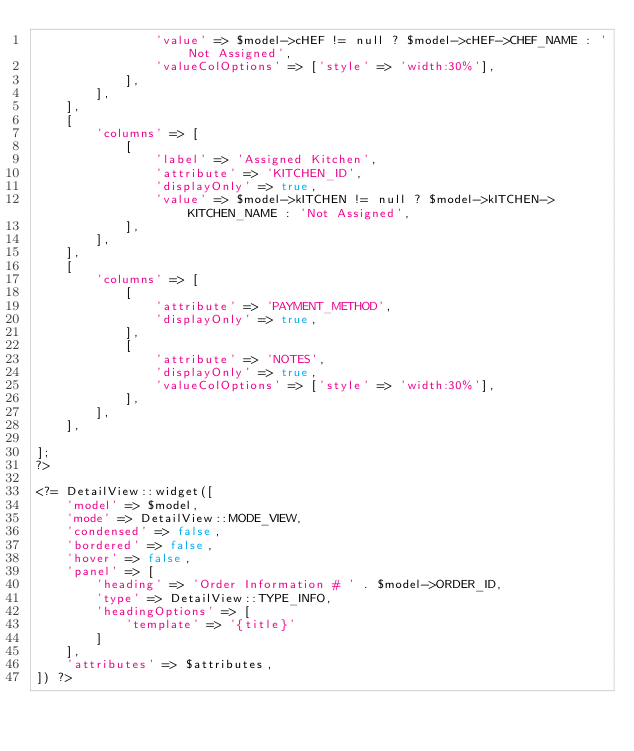Convert code to text. <code><loc_0><loc_0><loc_500><loc_500><_PHP_>                'value' => $model->cHEF != null ? $model->cHEF->CHEF_NAME : 'Not Assigned',
                'valueColOptions' => ['style' => 'width:30%'],
            ],
        ],
    ],
    [
        'columns' => [
            [
                'label' => 'Assigned Kitchen',
                'attribute' => 'KITCHEN_ID',
                'displayOnly' => true,
                'value' => $model->kITCHEN != null ? $model->kITCHEN->KITCHEN_NAME : 'Not Assigned',
            ],
        ],
    ],
    [
        'columns' => [
            [
                'attribute' => 'PAYMENT_METHOD',
                'displayOnly' => true,
            ],
            [
                'attribute' => 'NOTES',
                'displayOnly' => true,
                'valueColOptions' => ['style' => 'width:30%'],
            ],
        ],
    ],

];
?>

<?= DetailView::widget([
    'model' => $model,
    'mode' => DetailView::MODE_VIEW,
    'condensed' => false,
    'bordered' => false,
    'hover' => false,
    'panel' => [
        'heading' => 'Order Information # ' . $model->ORDER_ID,
        'type' => DetailView::TYPE_INFO,
        'headingOptions' => [
            'template' => '{title}'
        ]
    ],
    'attributes' => $attributes,
]) ?></code> 